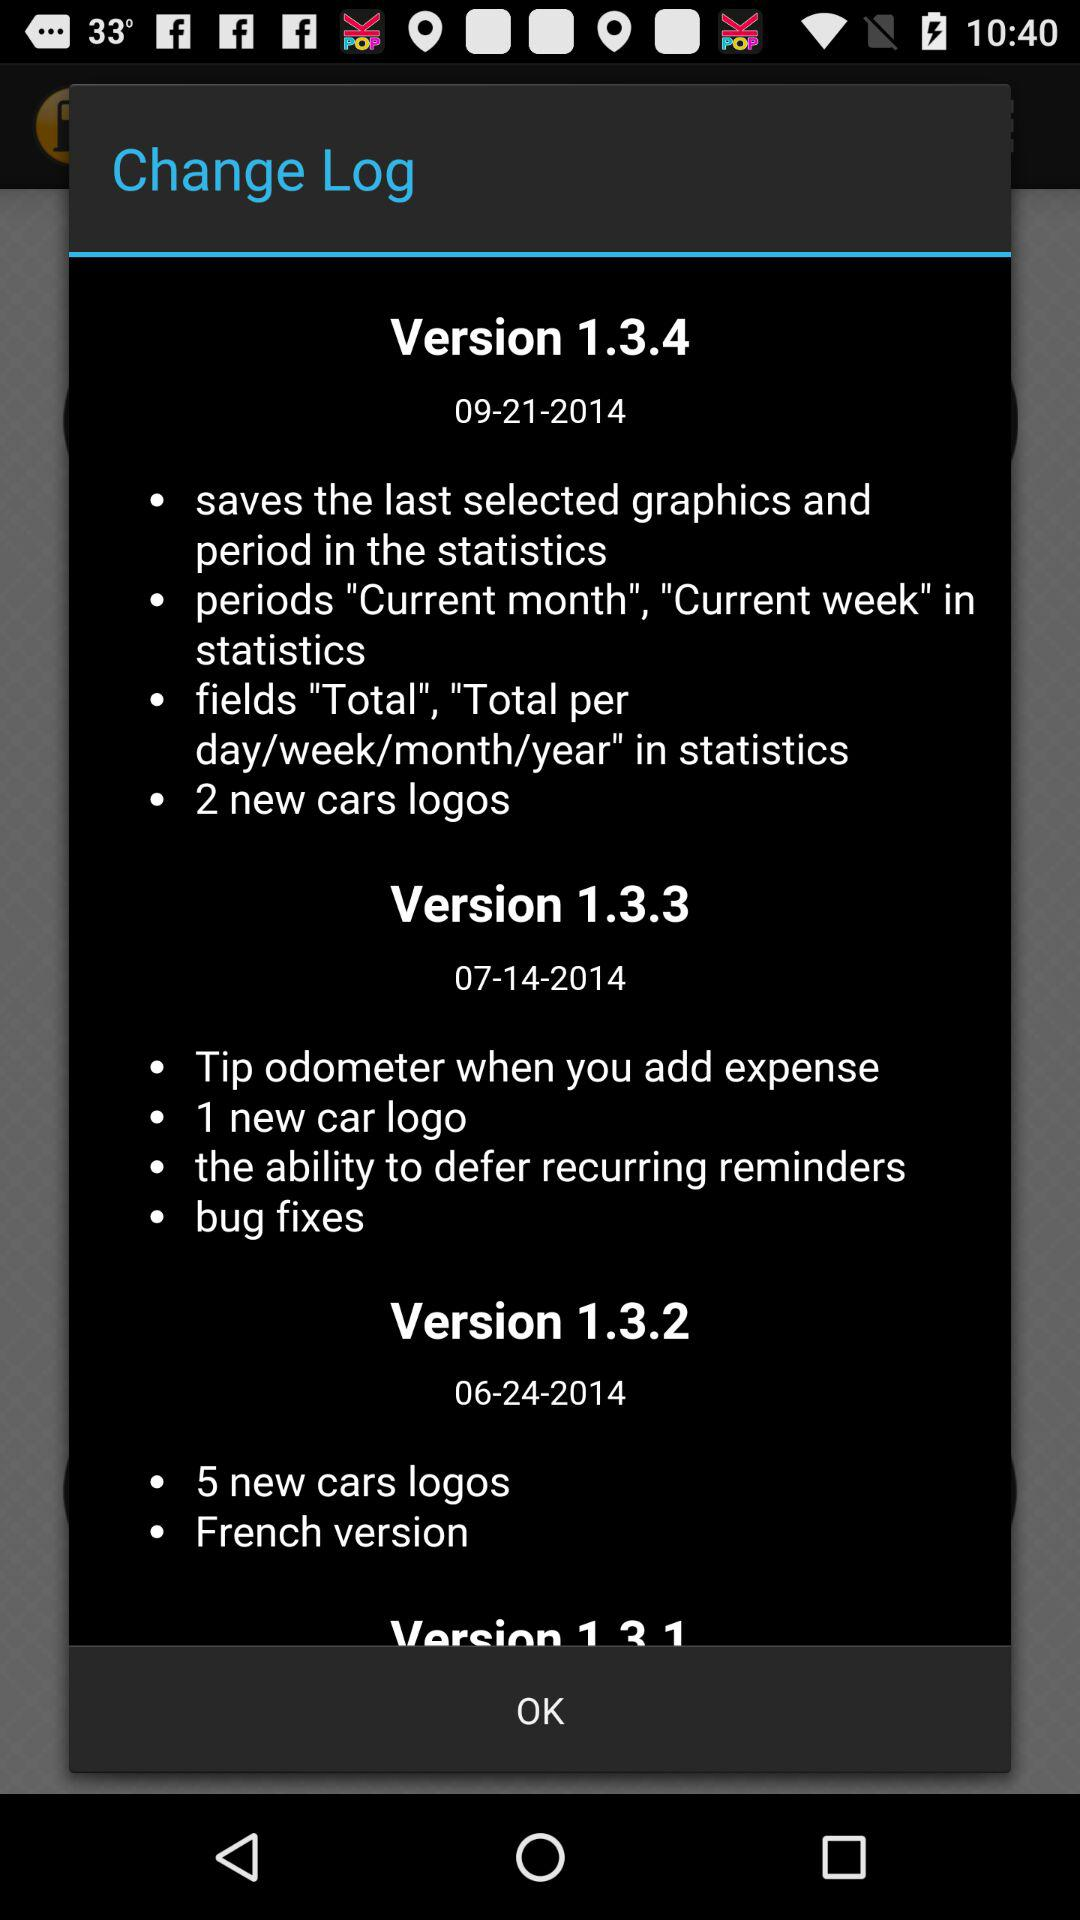How many new car logos are added in version 1.3.4?
Answer the question using a single word or phrase. 2 